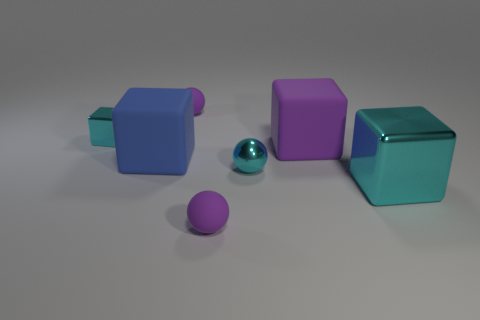Subtract 2 cubes. How many cubes are left? 2 Add 1 large blue rubber cylinders. How many objects exist? 8 Subtract all brown blocks. Subtract all green spheres. How many blocks are left? 4 Subtract all cubes. How many objects are left? 3 Subtract 0 gray cubes. How many objects are left? 7 Subtract all large green metallic balls. Subtract all tiny matte things. How many objects are left? 5 Add 5 tiny purple spheres. How many tiny purple spheres are left? 7 Add 1 tiny red balls. How many tiny red balls exist? 1 